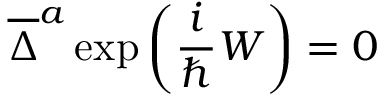<formula> <loc_0><loc_0><loc_500><loc_500>\overline { \Delta } ^ { a } \exp \left ( \frac { i } { \hbar } { W } \right ) = 0</formula> 